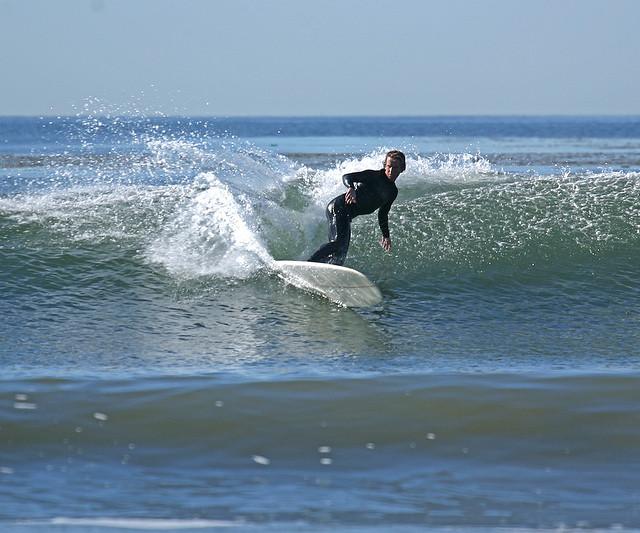What color is the surfboard?
Keep it brief. White. How is the person keeping their balance?
Concise answer only. Weight shift. Is this guy just starting to surf, or is he finishing a surfing pass?
Answer briefly. Finishing. 